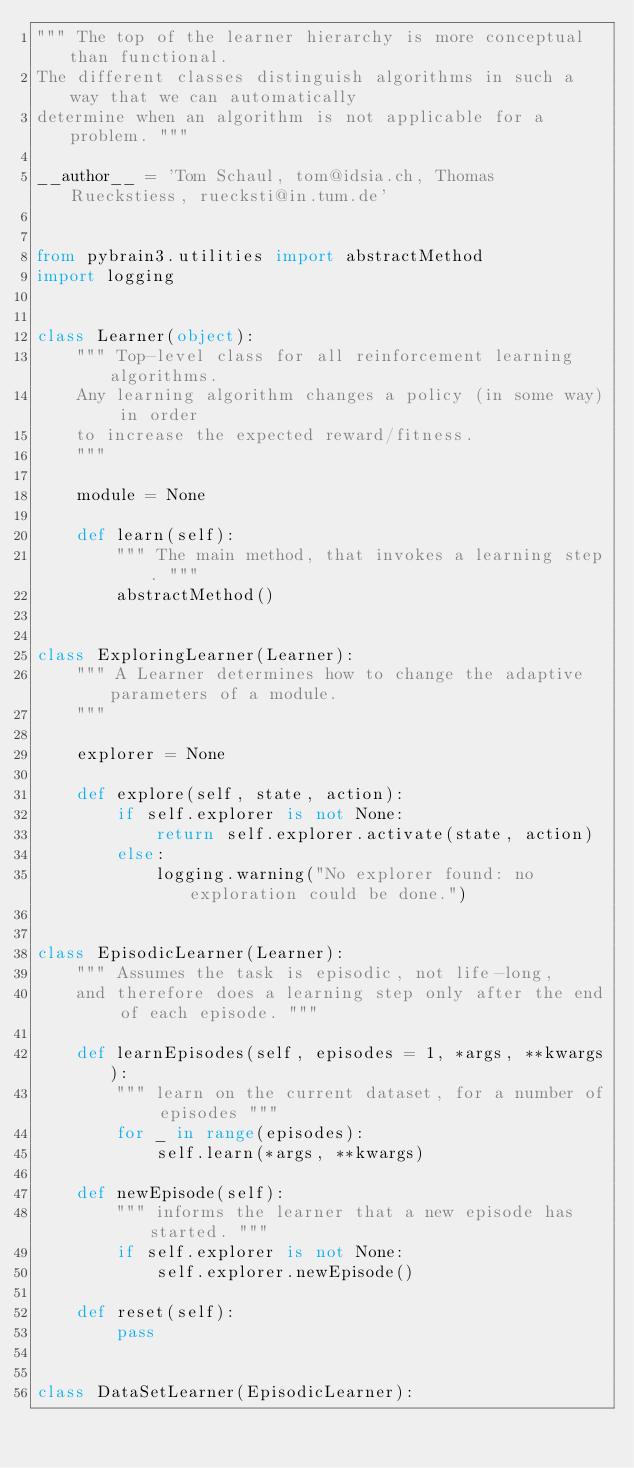<code> <loc_0><loc_0><loc_500><loc_500><_Python_>""" The top of the learner hierarchy is more conceptual than functional. 
The different classes distinguish algorithms in such a way that we can automatically 
determine when an algorithm is not applicable for a problem. """

__author__ = 'Tom Schaul, tom@idsia.ch, Thomas Rueckstiess, ruecksti@in.tum.de'


from pybrain3.utilities import abstractMethod
import logging


class Learner(object):
    """ Top-level class for all reinforcement learning algorithms.
    Any learning algorithm changes a policy (in some way) in order 
    to increase the expected reward/fitness. 
    """
    
    module = None    
    
    def learn(self):
        """ The main method, that invokes a learning step. """
        abstractMethod()
        
    
class ExploringLearner(Learner):
    """ A Learner determines how to change the adaptive parameters of a module.
    """

    explorer = None    
    
    def explore(self, state, action):
        if self.explorer is not None:
            return self.explorer.activate(state, action)
        else:
            logging.warning("No explorer found: no exploration could be done.")
                    
    
class EpisodicLearner(Learner):
    """ Assumes the task is episodic, not life-long,
    and therefore does a learning step only after the end of each episode. """

    def learnEpisodes(self, episodes = 1, *args, **kwargs):
        """ learn on the current dataset, for a number of episodes """
        for _ in range(episodes):
            self.learn(*args, **kwargs)
            
    def newEpisode(self):
        """ informs the learner that a new episode has started. """
        if self.explorer is not None:
            self.explorer.newEpisode()
            
    def reset(self):
        pass


class DataSetLearner(EpisodicLearner):</code> 